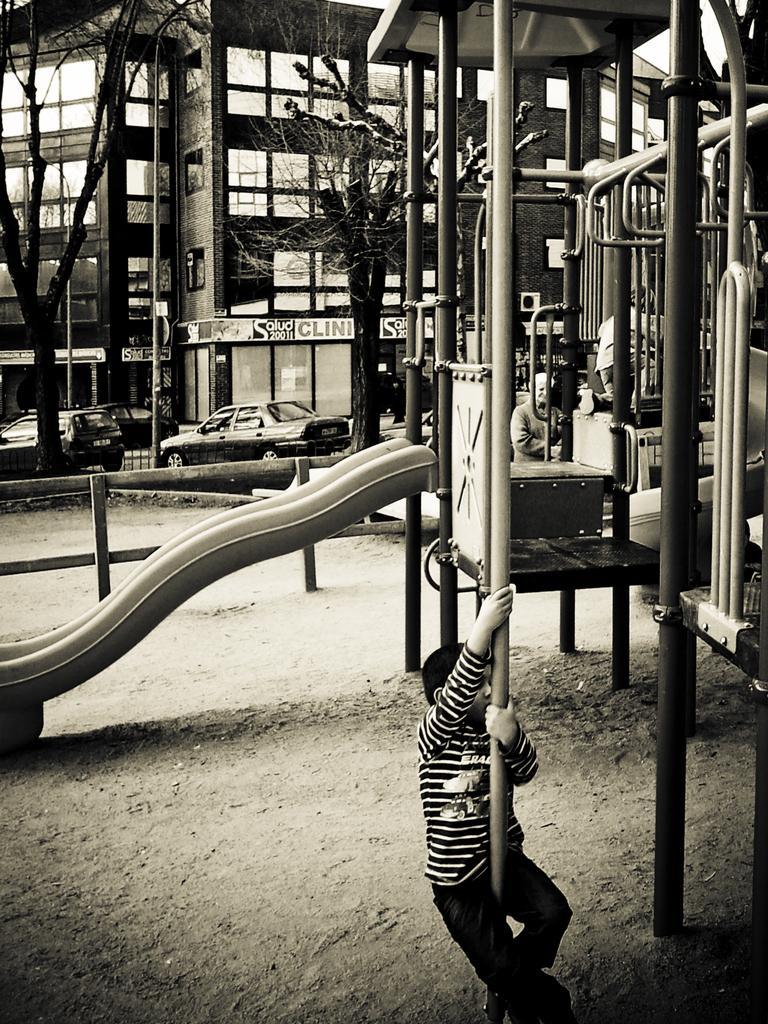Could you give a brief overview of what you see in this image? In this picture I can see building and few cars and I can see trees and I can see play zone and a boy holding a metal rod and I can see another kid on the slider, looks like a human in the back. 